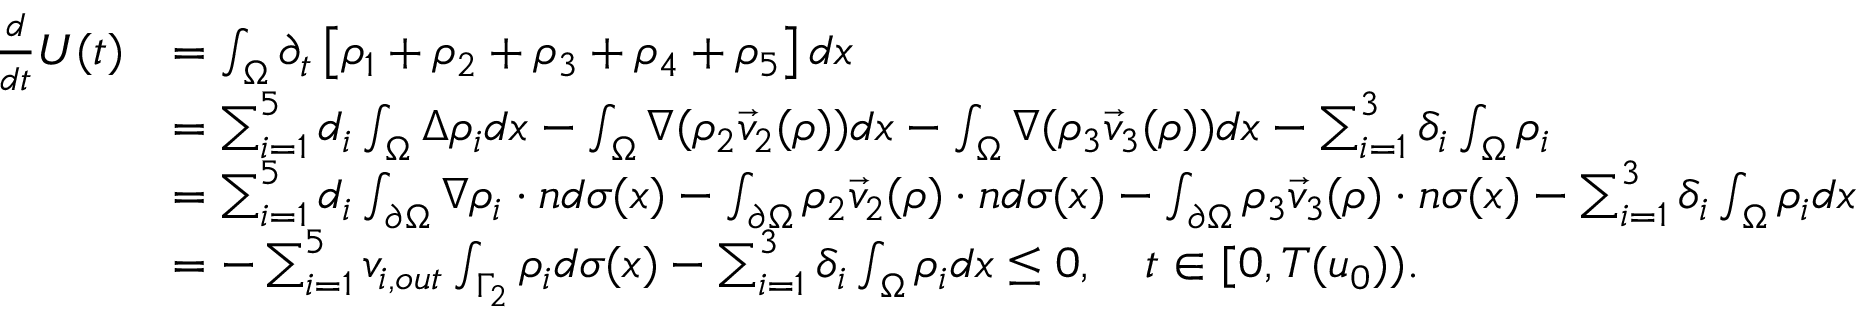Convert formula to latex. <formula><loc_0><loc_0><loc_500><loc_500>\begin{array} { r l } { \frac { d } { d t } U ( t ) } & { = \int _ { \Omega } \partial _ { t } \left [ \rho _ { 1 } + \rho _ { 2 } + \rho _ { 3 } + \rho _ { 4 } + \rho _ { 5 } \right ] d x } \\ & { = \sum _ { i = 1 } ^ { 5 } d _ { i } \int _ { \Omega } \Delta \rho _ { i } d x - \int _ { \Omega } \nabla ( \rho _ { 2 } \vec { v } _ { 2 } ( \rho ) ) d x - \int _ { \Omega } \nabla ( \rho _ { 3 } \vec { v } _ { 3 } ( \rho ) ) d x - \sum _ { i = 1 } ^ { 3 } \delta _ { i } \int _ { \Omega } \rho _ { i } } \\ & { = \sum _ { i = 1 } ^ { 5 } d _ { i } \int _ { \partial \Omega } \nabla \rho _ { i } \cdot n d \sigma ( x ) - \int _ { \partial \Omega } \rho _ { 2 } \vec { v } _ { 2 } ( \rho ) \cdot n d \sigma ( x ) - \int _ { \partial \Omega } \rho _ { 3 } \vec { v } _ { 3 } ( \rho ) \cdot n \sigma ( x ) - \sum _ { i = 1 } ^ { 3 } \delta _ { i } \int _ { \Omega } \rho _ { i } d x } \\ & { = - \sum _ { i = 1 } ^ { 5 } v _ { i , o u t } \int _ { \Gamma _ { 2 } } \rho _ { i } d \sigma ( x ) - \sum _ { i = 1 } ^ { 3 } \delta _ { i } \int _ { \Omega } \rho _ { i } d x \leq 0 , \quad t \in [ 0 , T ( u _ { 0 } ) ) . } \end{array}</formula> 